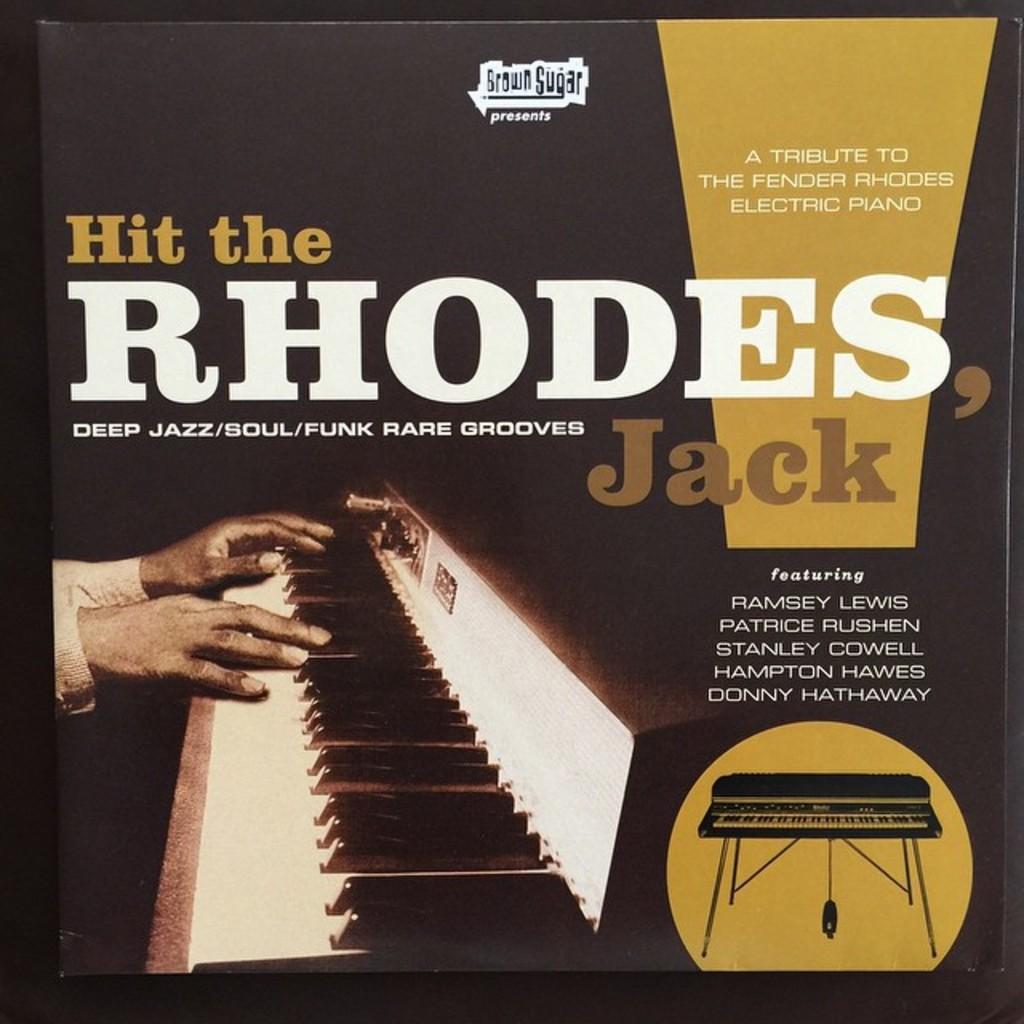Can you describe this image briefly? In this image there is a poster, on that poster there is some text and a piano, on that piano there are hands. 